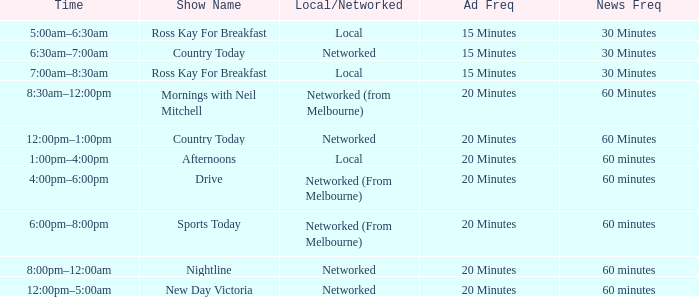What News Freq has a Time of 1:00pm–4:00pm? 60 minutes. 